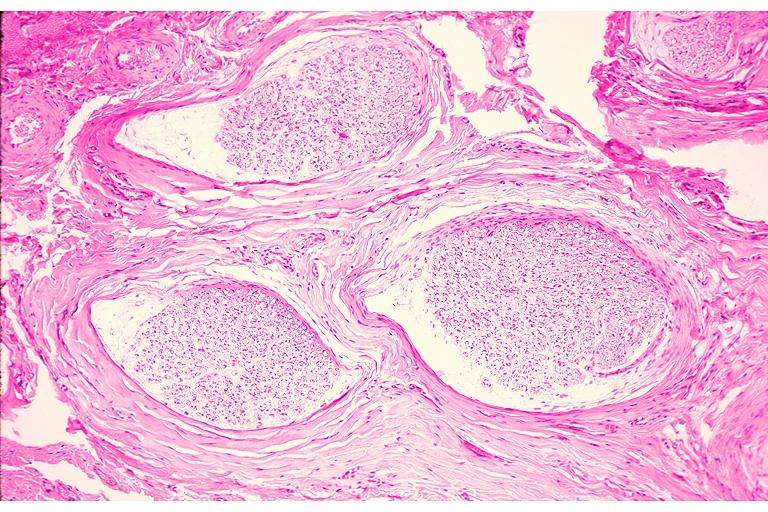s this person present?
Answer the question using a single word or phrase. No 